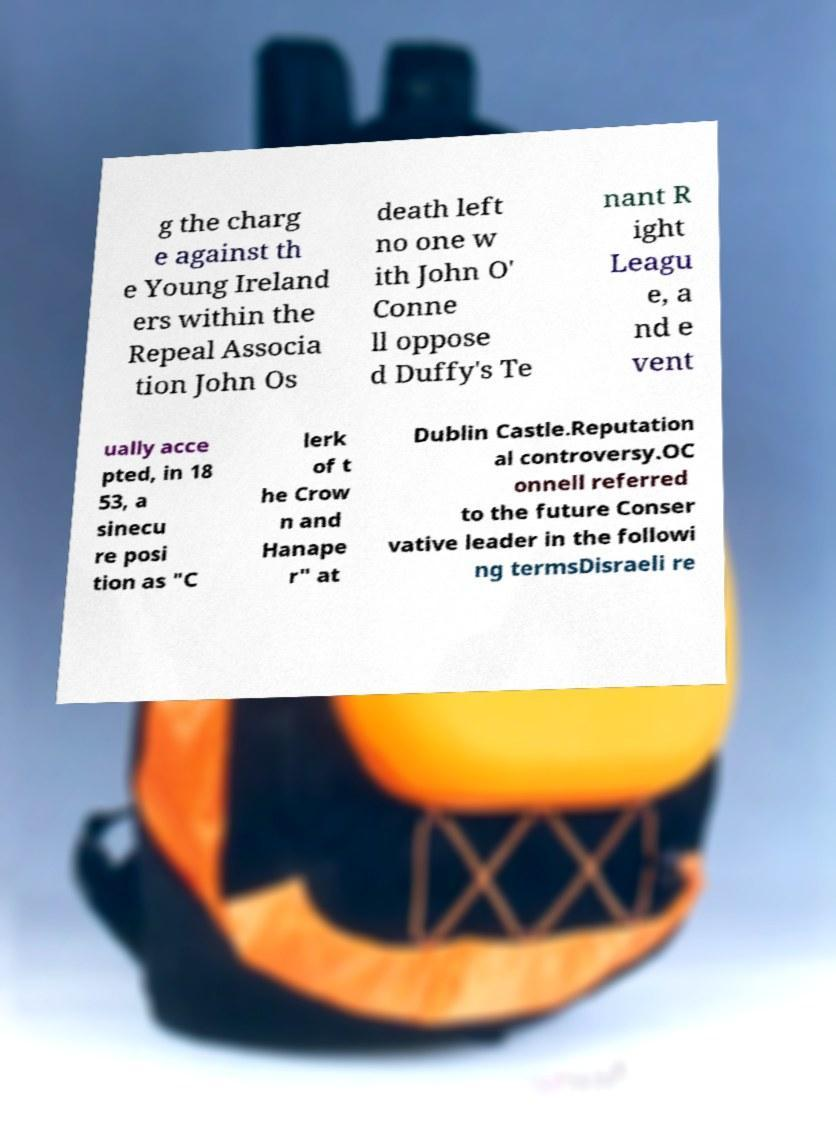I need the written content from this picture converted into text. Can you do that? g the charg e against th e Young Ireland ers within the Repeal Associa tion John Os death left no one w ith John O' Conne ll oppose d Duffy's Te nant R ight Leagu e, a nd e vent ually acce pted, in 18 53, a sinecu re posi tion as "C lerk of t he Crow n and Hanape r" at Dublin Castle.Reputation al controversy.OC onnell referred to the future Conser vative leader in the followi ng termsDisraeli re 